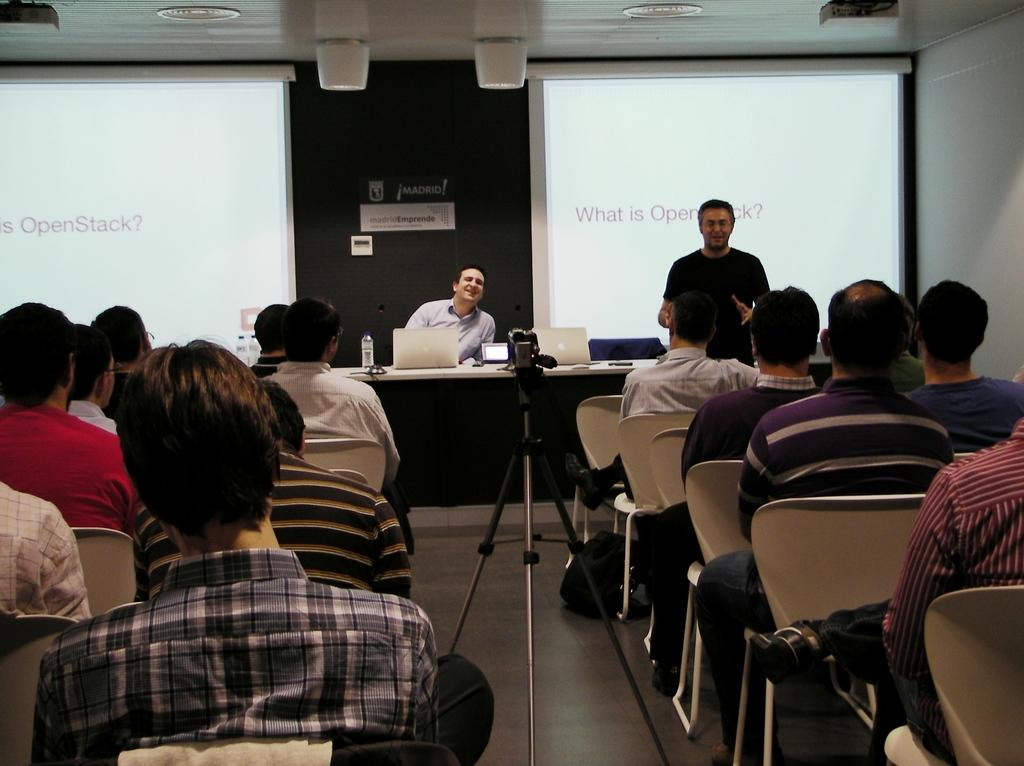What is the main object in the image? There is a screen in the image. What are the people in the image doing? The people are sitting on chairs in the image. What device is used to capture images in the image? There is a camera in the image. What piece of furniture is present in the image? There is a table in the image. What electronic devices are on the table? There are laptops on the table. What is the additional item on the table? There is a bottle on the table. What is the size of the park visible in the image? There is no park present in the image; it features a screen, chairs, a camera, a table, laptops, and a bottle. How long is the journey depicted in the image? There is no journey depicted in the image; it focuses on a screen, chairs, a camera, a table, laptops, and a bottle. 